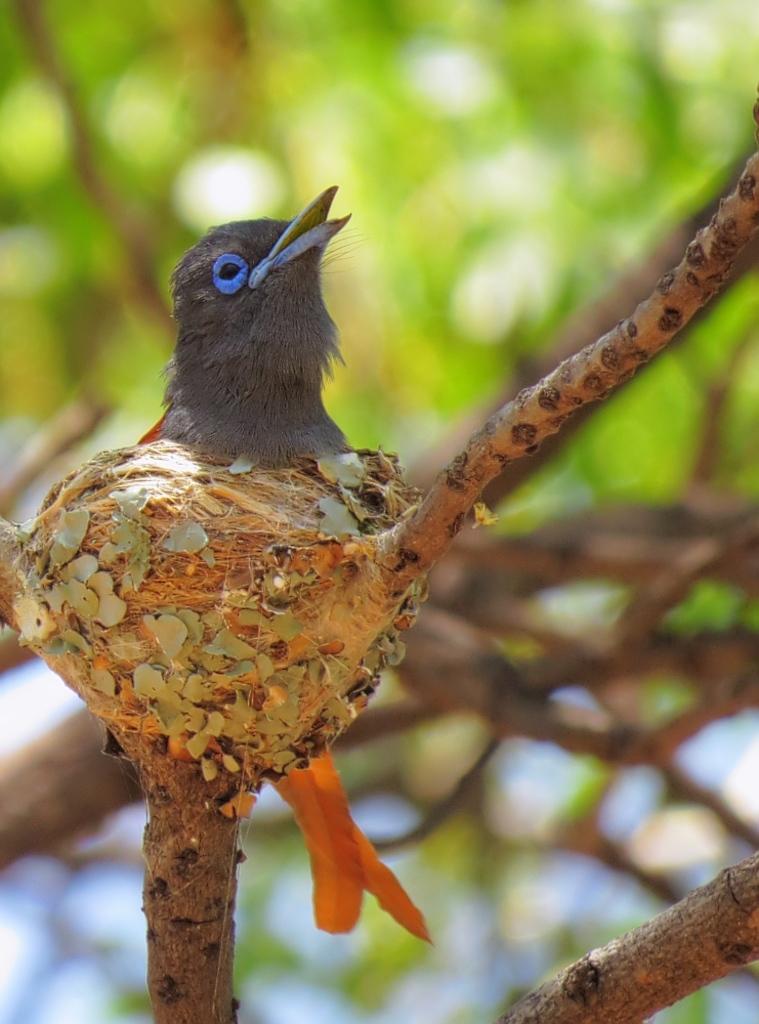In one or two sentences, can you explain what this image depicts? In this picture we can observe a bird which is in black and orange color. The bird is on the branch of a tree. In the background we can observe green color tree. 